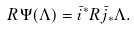<formula> <loc_0><loc_0><loc_500><loc_500>R \Psi ( \Lambda ) = \bar { i } ^ { * } R \bar { j } _ { * } \Lambda .</formula> 